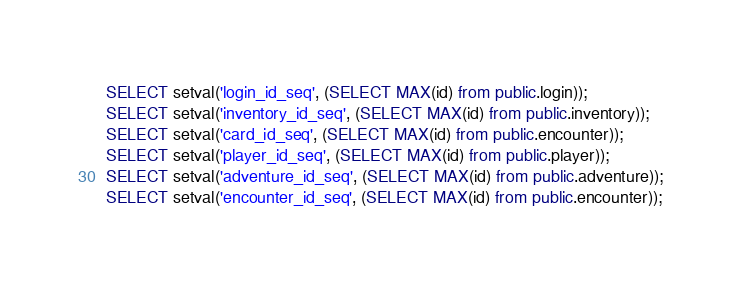Convert code to text. <code><loc_0><loc_0><loc_500><loc_500><_SQL_>SELECT setval('login_id_seq', (SELECT MAX(id) from public.login));
SELECT setval('inventory_id_seq', (SELECT MAX(id) from public.inventory));
SELECT setval('card_id_seq', (SELECT MAX(id) from public.encounter));
SELECT setval('player_id_seq', (SELECT MAX(id) from public.player));
SELECT setval('adventure_id_seq', (SELECT MAX(id) from public.adventure));
SELECT setval('encounter_id_seq', (SELECT MAX(id) from public.encounter));
</code> 